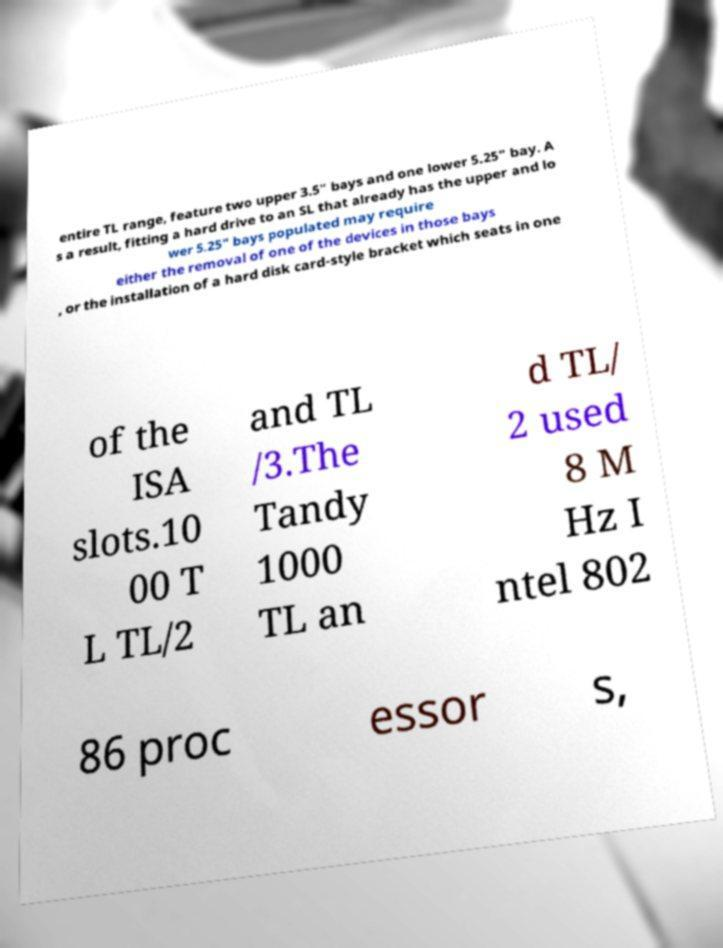Please read and relay the text visible in this image. What does it say? entire TL range, feature two upper 3.5" bays and one lower 5.25" bay. A s a result, fitting a hard drive to an SL that already has the upper and lo wer 5.25" bays populated may require either the removal of one of the devices in those bays , or the installation of a hard disk card-style bracket which seats in one of the ISA slots.10 00 T L TL/2 and TL /3.The Tandy 1000 TL an d TL/ 2 used 8 M Hz I ntel 802 86 proc essor s, 